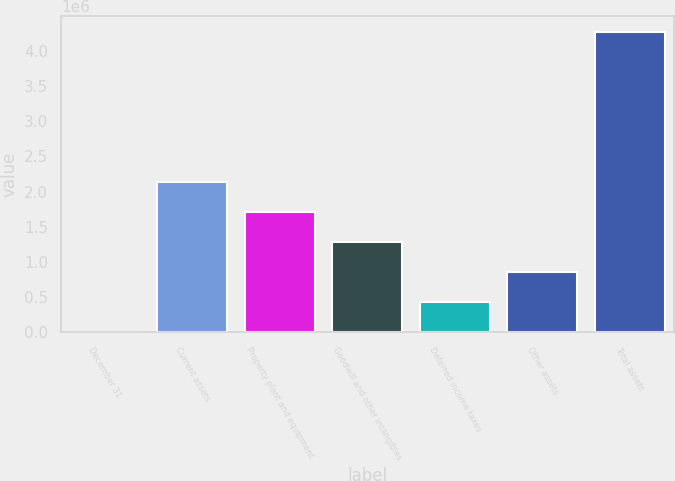Convert chart. <chart><loc_0><loc_0><loc_500><loc_500><bar_chart><fcel>December 31<fcel>Current assets<fcel>Property plant and equipment<fcel>Goodwill and other intangibles<fcel>Deferred income taxes<fcel>Other assets<fcel>Total assets<nl><fcel>2010<fcel>2.13737e+06<fcel>1.7103e+06<fcel>1.28323e+06<fcel>429082<fcel>856154<fcel>4.27273e+06<nl></chart> 